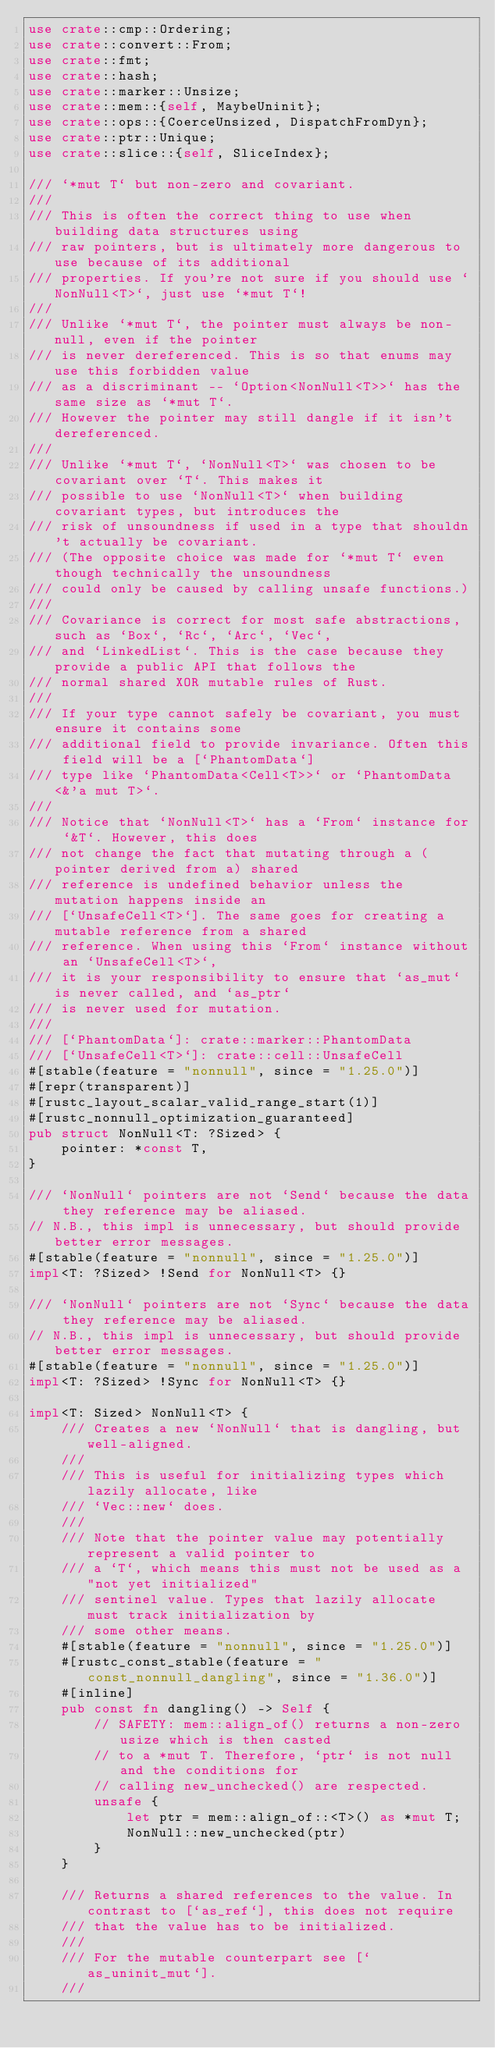<code> <loc_0><loc_0><loc_500><loc_500><_Rust_>use crate::cmp::Ordering;
use crate::convert::From;
use crate::fmt;
use crate::hash;
use crate::marker::Unsize;
use crate::mem::{self, MaybeUninit};
use crate::ops::{CoerceUnsized, DispatchFromDyn};
use crate::ptr::Unique;
use crate::slice::{self, SliceIndex};

/// `*mut T` but non-zero and covariant.
///
/// This is often the correct thing to use when building data structures using
/// raw pointers, but is ultimately more dangerous to use because of its additional
/// properties. If you're not sure if you should use `NonNull<T>`, just use `*mut T`!
///
/// Unlike `*mut T`, the pointer must always be non-null, even if the pointer
/// is never dereferenced. This is so that enums may use this forbidden value
/// as a discriminant -- `Option<NonNull<T>>` has the same size as `*mut T`.
/// However the pointer may still dangle if it isn't dereferenced.
///
/// Unlike `*mut T`, `NonNull<T>` was chosen to be covariant over `T`. This makes it
/// possible to use `NonNull<T>` when building covariant types, but introduces the
/// risk of unsoundness if used in a type that shouldn't actually be covariant.
/// (The opposite choice was made for `*mut T` even though technically the unsoundness
/// could only be caused by calling unsafe functions.)
///
/// Covariance is correct for most safe abstractions, such as `Box`, `Rc`, `Arc`, `Vec`,
/// and `LinkedList`. This is the case because they provide a public API that follows the
/// normal shared XOR mutable rules of Rust.
///
/// If your type cannot safely be covariant, you must ensure it contains some
/// additional field to provide invariance. Often this field will be a [`PhantomData`]
/// type like `PhantomData<Cell<T>>` or `PhantomData<&'a mut T>`.
///
/// Notice that `NonNull<T>` has a `From` instance for `&T`. However, this does
/// not change the fact that mutating through a (pointer derived from a) shared
/// reference is undefined behavior unless the mutation happens inside an
/// [`UnsafeCell<T>`]. The same goes for creating a mutable reference from a shared
/// reference. When using this `From` instance without an `UnsafeCell<T>`,
/// it is your responsibility to ensure that `as_mut` is never called, and `as_ptr`
/// is never used for mutation.
///
/// [`PhantomData`]: crate::marker::PhantomData
/// [`UnsafeCell<T>`]: crate::cell::UnsafeCell
#[stable(feature = "nonnull", since = "1.25.0")]
#[repr(transparent)]
#[rustc_layout_scalar_valid_range_start(1)]
#[rustc_nonnull_optimization_guaranteed]
pub struct NonNull<T: ?Sized> {
    pointer: *const T,
}

/// `NonNull` pointers are not `Send` because the data they reference may be aliased.
// N.B., this impl is unnecessary, but should provide better error messages.
#[stable(feature = "nonnull", since = "1.25.0")]
impl<T: ?Sized> !Send for NonNull<T> {}

/// `NonNull` pointers are not `Sync` because the data they reference may be aliased.
// N.B., this impl is unnecessary, but should provide better error messages.
#[stable(feature = "nonnull", since = "1.25.0")]
impl<T: ?Sized> !Sync for NonNull<T> {}

impl<T: Sized> NonNull<T> {
    /// Creates a new `NonNull` that is dangling, but well-aligned.
    ///
    /// This is useful for initializing types which lazily allocate, like
    /// `Vec::new` does.
    ///
    /// Note that the pointer value may potentially represent a valid pointer to
    /// a `T`, which means this must not be used as a "not yet initialized"
    /// sentinel value. Types that lazily allocate must track initialization by
    /// some other means.
    #[stable(feature = "nonnull", since = "1.25.0")]
    #[rustc_const_stable(feature = "const_nonnull_dangling", since = "1.36.0")]
    #[inline]
    pub const fn dangling() -> Self {
        // SAFETY: mem::align_of() returns a non-zero usize which is then casted
        // to a *mut T. Therefore, `ptr` is not null and the conditions for
        // calling new_unchecked() are respected.
        unsafe {
            let ptr = mem::align_of::<T>() as *mut T;
            NonNull::new_unchecked(ptr)
        }
    }

    /// Returns a shared references to the value. In contrast to [`as_ref`], this does not require
    /// that the value has to be initialized.
    ///
    /// For the mutable counterpart see [`as_uninit_mut`].
    ///</code> 